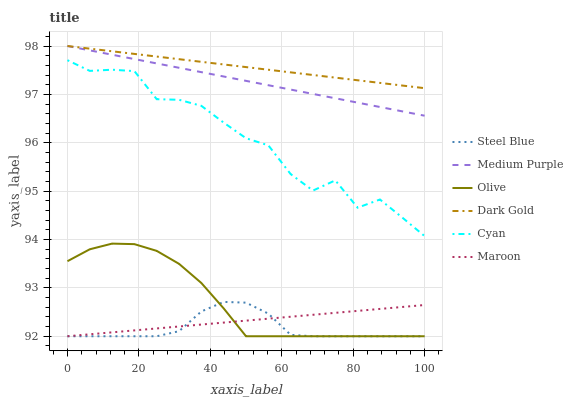Does Steel Blue have the minimum area under the curve?
Answer yes or no. Yes. Does Dark Gold have the maximum area under the curve?
Answer yes or no. Yes. Does Maroon have the minimum area under the curve?
Answer yes or no. No. Does Maroon have the maximum area under the curve?
Answer yes or no. No. Is Medium Purple the smoothest?
Answer yes or no. Yes. Is Cyan the roughest?
Answer yes or no. Yes. Is Steel Blue the smoothest?
Answer yes or no. No. Is Steel Blue the roughest?
Answer yes or no. No. Does Steel Blue have the lowest value?
Answer yes or no. Yes. Does Medium Purple have the lowest value?
Answer yes or no. No. Does Medium Purple have the highest value?
Answer yes or no. Yes. Does Steel Blue have the highest value?
Answer yes or no. No. Is Maroon less than Dark Gold?
Answer yes or no. Yes. Is Medium Purple greater than Steel Blue?
Answer yes or no. Yes. Does Olive intersect Steel Blue?
Answer yes or no. Yes. Is Olive less than Steel Blue?
Answer yes or no. No. Is Olive greater than Steel Blue?
Answer yes or no. No. Does Maroon intersect Dark Gold?
Answer yes or no. No. 